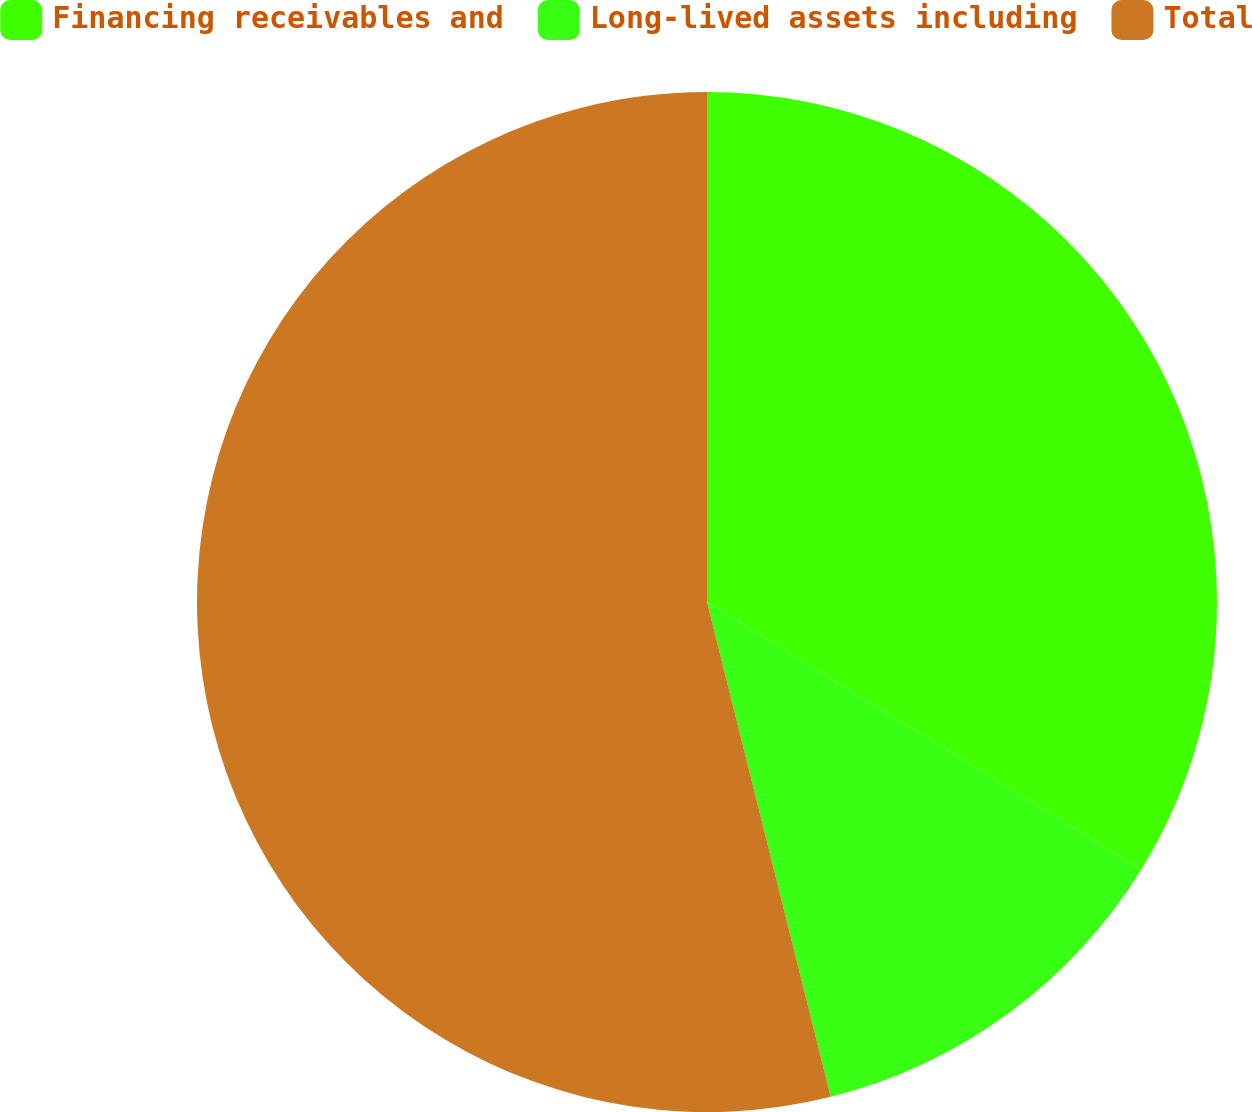Convert chart to OTSL. <chart><loc_0><loc_0><loc_500><loc_500><pie_chart><fcel>Financing receivables and<fcel>Long-lived assets including<fcel>Total<nl><fcel>33.79%<fcel>12.31%<fcel>53.9%<nl></chart> 